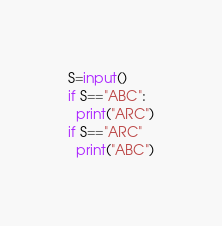Convert code to text. <code><loc_0><loc_0><loc_500><loc_500><_Python_>S=input()
if S=="ABC":
  print("ARC")
if S=="ARC"
  print("ABC")</code> 